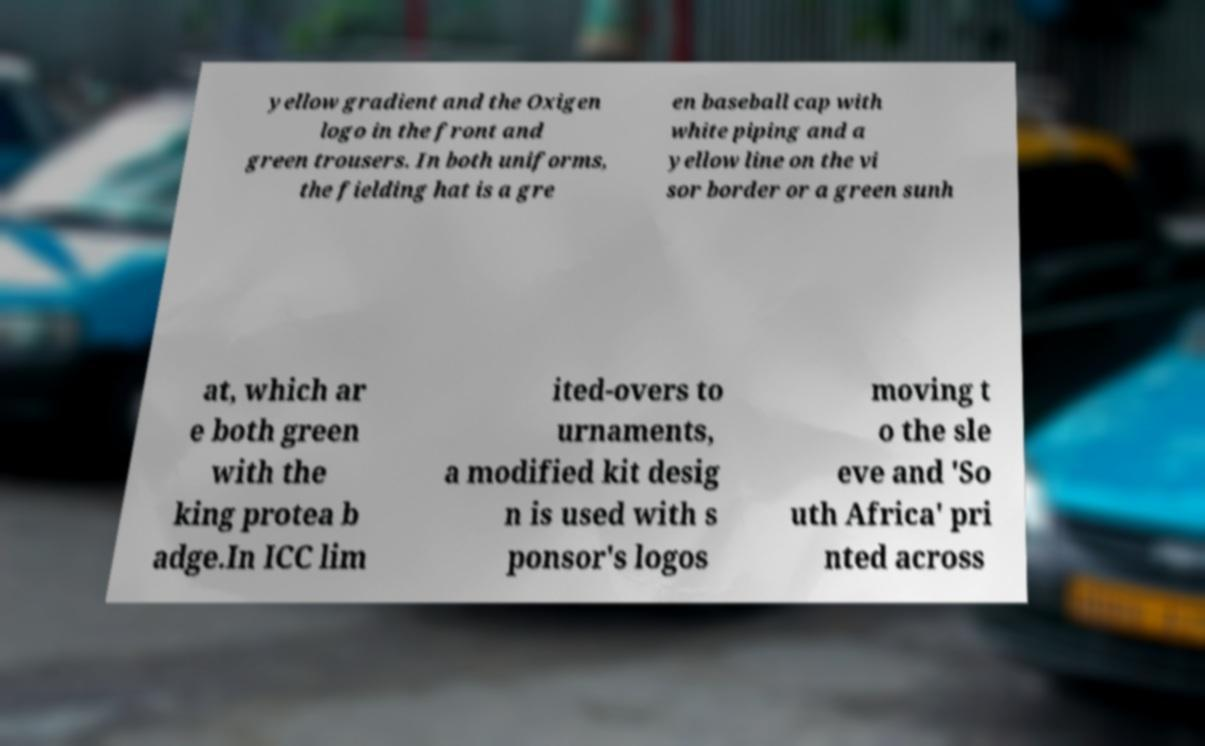Can you accurately transcribe the text from the provided image for me? yellow gradient and the Oxigen logo in the front and green trousers. In both uniforms, the fielding hat is a gre en baseball cap with white piping and a yellow line on the vi sor border or a green sunh at, which ar e both green with the king protea b adge.In ICC lim ited-overs to urnaments, a modified kit desig n is used with s ponsor's logos moving t o the sle eve and 'So uth Africa' pri nted across 